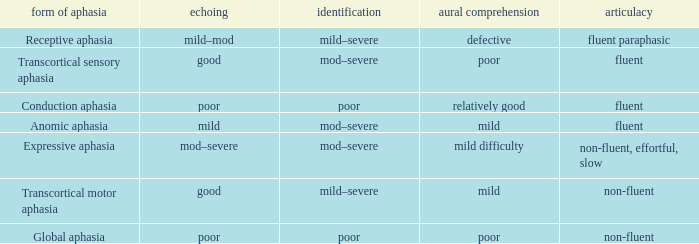Name the number of naming for anomic aphasia 1.0. 